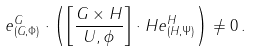Convert formula to latex. <formula><loc_0><loc_0><loc_500><loc_500>e _ { ( G , \Phi ) } ^ { G } \cdot \left ( \left [ \frac { G \times H } { U , \phi } \right ] \cdot H e _ { ( H , \Psi ) } ^ { H } \right ) \neq 0 \, .</formula> 